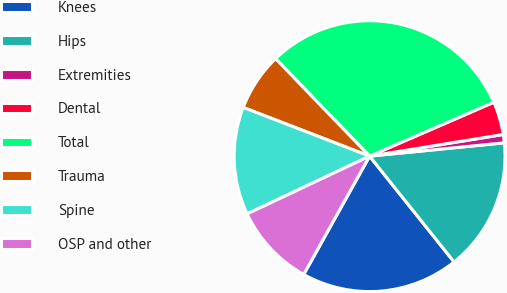Convert chart. <chart><loc_0><loc_0><loc_500><loc_500><pie_chart><fcel>Knees<fcel>Hips<fcel>Extremities<fcel>Dental<fcel>Total<fcel>Trauma<fcel>Spine<fcel>OSP and other<nl><fcel>18.81%<fcel>15.84%<fcel>0.99%<fcel>3.96%<fcel>30.69%<fcel>6.93%<fcel>12.87%<fcel>9.9%<nl></chart> 